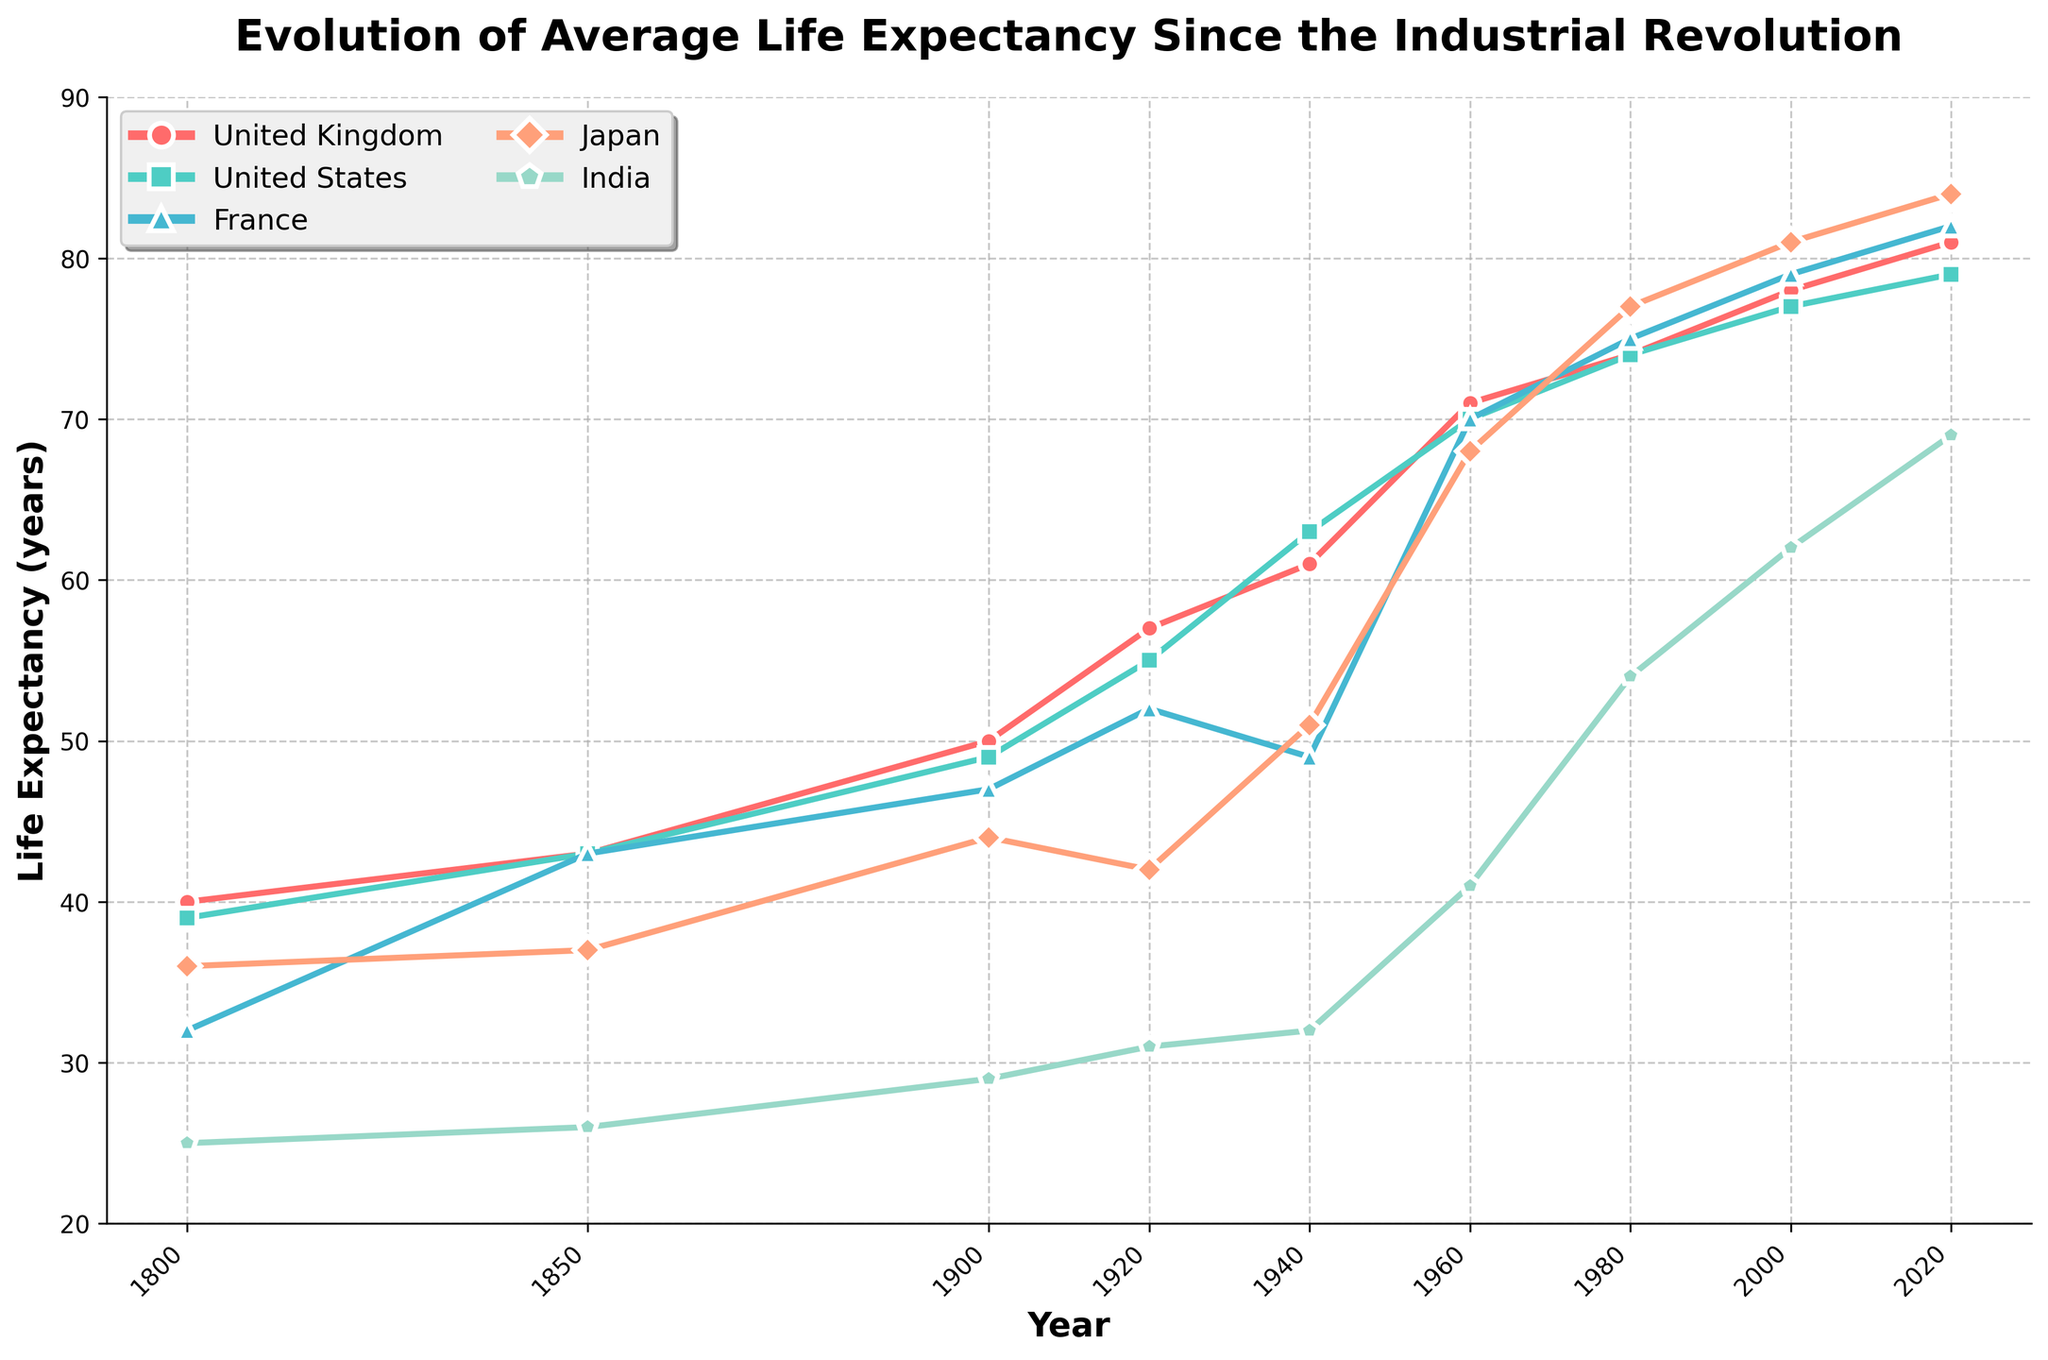What's the trend in life expectancy for Japan from 1800 to 2020? Starting at 36 years in 1800, there are gradual increments up to 37 in 1850, significant jumps to 44 in 1900, a dip to 42 in 1920, increased to 51 in 1940, sharply rises to 68 by 1960, 77 in 1980, 81 in 2000, and peaks at 84 by 2020
Answer: Increasing trend Which country had the highest life expectancy in the year 2000? Comparing the values for the year 2000, United Kingdom (78), United States (77), France (79), Japan (81), India (62), Japan had the highest life expectancy at 81 years
Answer: Japan By how many years did life expectancy in India increase from 1900 to 2000? The life expectancy in India in 1900 was 29 years and in 2000 it was 62 years. The increase is calculated as 62 - 29 = 33
Answer: 33 years Compare the life expectancy of France and the United States in the year 1920. Which was higher and by how much? In 1920, France had a life expectancy of 52 years, and the United States had 55 years. The difference is 55 - 52 = 3 years
Answer: United States, by 3 years What notable trend do you observe for the United Kingdom's life expectancy between 1800 and 2000? Analyzing the timeline, the life expectancy increases consistently from 40 years in 1800 to 78 years in 2000, reflecting an overall consistent rise
Answer: Consistent rise In which decade did Japan experience the most significant increase in life expectancy? Comparing every decade, from 1940 (51 years) to 1960 (68 years), there is an increase of 17 years, which is the most significant increase observed
Answer: 1940s to 1950s Which country had the slowest increase in life expectancy from 1800 to 2020? By comparing the beginning and ending points, India increased from 25 to 69 years, an increment of 44 years, which is less compared to other countries
Answer: India Between 1960 and 1980, which country saw the smallest improvement in life expectancy? For 1960: United Kingdom (71), United States (70), France (70), Japan (68), India (41). For 1980: United Kingdom (74), United States (74), France (75), Japan (77), India (54). UK saw the increase by 3 years (74-71), the smallest among others
Answer: United Kingdom What is the rate of life expectancy improvement in France from 1800 to 1920? Starting at 32 years in 1800 and reaching 52 years in 1920, the improvement rate is 52 - 32 = 20 years over 120 years. Divide 20 by 120 to get the rate = 20/120 = 0.167 years/year
Answer: 0.167 years/year 